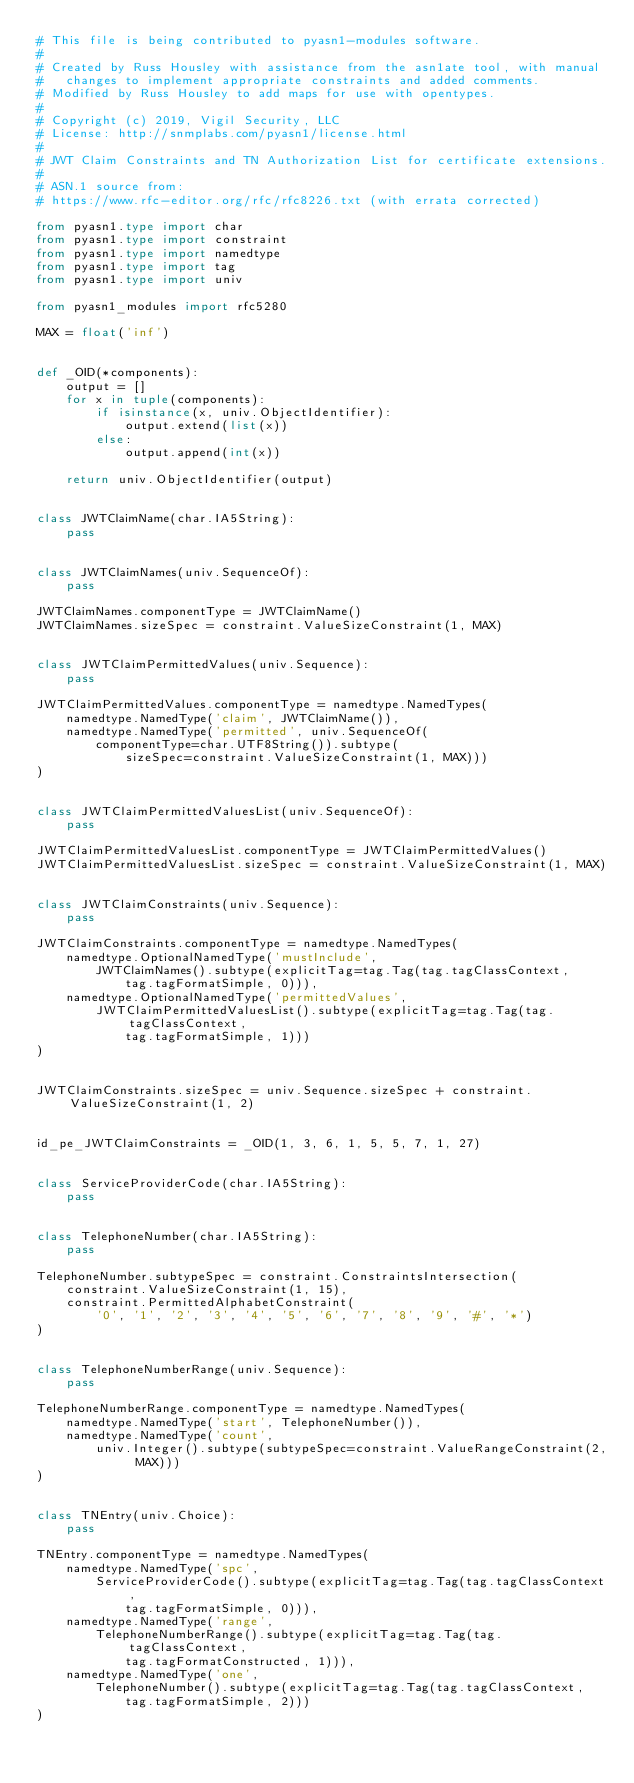<code> <loc_0><loc_0><loc_500><loc_500><_Python_># This file is being contributed to pyasn1-modules software.
#
# Created by Russ Housley with assistance from the asn1ate tool, with manual
#   changes to implement appropriate constraints and added comments.
# Modified by Russ Housley to add maps for use with opentypes.
#
# Copyright (c) 2019, Vigil Security, LLC
# License: http://snmplabs.com/pyasn1/license.html
#
# JWT Claim Constraints and TN Authorization List for certificate extensions.
#
# ASN.1 source from:
# https://www.rfc-editor.org/rfc/rfc8226.txt (with errata corrected)

from pyasn1.type import char
from pyasn1.type import constraint
from pyasn1.type import namedtype
from pyasn1.type import tag
from pyasn1.type import univ

from pyasn1_modules import rfc5280

MAX = float('inf')


def _OID(*components):
    output = []
    for x in tuple(components):
        if isinstance(x, univ.ObjectIdentifier):
            output.extend(list(x))
        else:
            output.append(int(x))

    return univ.ObjectIdentifier(output)


class JWTClaimName(char.IA5String):
    pass


class JWTClaimNames(univ.SequenceOf):
    pass

JWTClaimNames.componentType = JWTClaimName()
JWTClaimNames.sizeSpec = constraint.ValueSizeConstraint(1, MAX)


class JWTClaimPermittedValues(univ.Sequence):
    pass

JWTClaimPermittedValues.componentType = namedtype.NamedTypes(
    namedtype.NamedType('claim', JWTClaimName()),
    namedtype.NamedType('permitted', univ.SequenceOf(
        componentType=char.UTF8String()).subtype(
            sizeSpec=constraint.ValueSizeConstraint(1, MAX)))
)


class JWTClaimPermittedValuesList(univ.SequenceOf):
    pass

JWTClaimPermittedValuesList.componentType = JWTClaimPermittedValues()
JWTClaimPermittedValuesList.sizeSpec = constraint.ValueSizeConstraint(1, MAX)


class JWTClaimConstraints(univ.Sequence):
    pass

JWTClaimConstraints.componentType = namedtype.NamedTypes(
    namedtype.OptionalNamedType('mustInclude',
        JWTClaimNames().subtype(explicitTag=tag.Tag(tag.tagClassContext,
            tag.tagFormatSimple, 0))),
    namedtype.OptionalNamedType('permittedValues',
        JWTClaimPermittedValuesList().subtype(explicitTag=tag.Tag(tag.tagClassContext,
            tag.tagFormatSimple, 1)))
)


JWTClaimConstraints.sizeSpec = univ.Sequence.sizeSpec + constraint.ValueSizeConstraint(1, 2)


id_pe_JWTClaimConstraints = _OID(1, 3, 6, 1, 5, 5, 7, 1, 27)


class ServiceProviderCode(char.IA5String):
    pass


class TelephoneNumber(char.IA5String):
    pass

TelephoneNumber.subtypeSpec = constraint.ConstraintsIntersection(
    constraint.ValueSizeConstraint(1, 15),
    constraint.PermittedAlphabetConstraint(
        '0', '1', '2', '3', '4', '5', '6', '7', '8', '9', '#', '*')
)


class TelephoneNumberRange(univ.Sequence):
    pass

TelephoneNumberRange.componentType = namedtype.NamedTypes(
    namedtype.NamedType('start', TelephoneNumber()),
    namedtype.NamedType('count',
        univ.Integer().subtype(subtypeSpec=constraint.ValueRangeConstraint(2, MAX)))
)


class TNEntry(univ.Choice):
    pass

TNEntry.componentType = namedtype.NamedTypes(
    namedtype.NamedType('spc',
        ServiceProviderCode().subtype(explicitTag=tag.Tag(tag.tagClassContext,
            tag.tagFormatSimple, 0))),
    namedtype.NamedType('range',
        TelephoneNumberRange().subtype(explicitTag=tag.Tag(tag.tagClassContext,
            tag.tagFormatConstructed, 1))),
    namedtype.NamedType('one',
        TelephoneNumber().subtype(explicitTag=tag.Tag(tag.tagClassContext,
            tag.tagFormatSimple, 2)))
)

</code> 